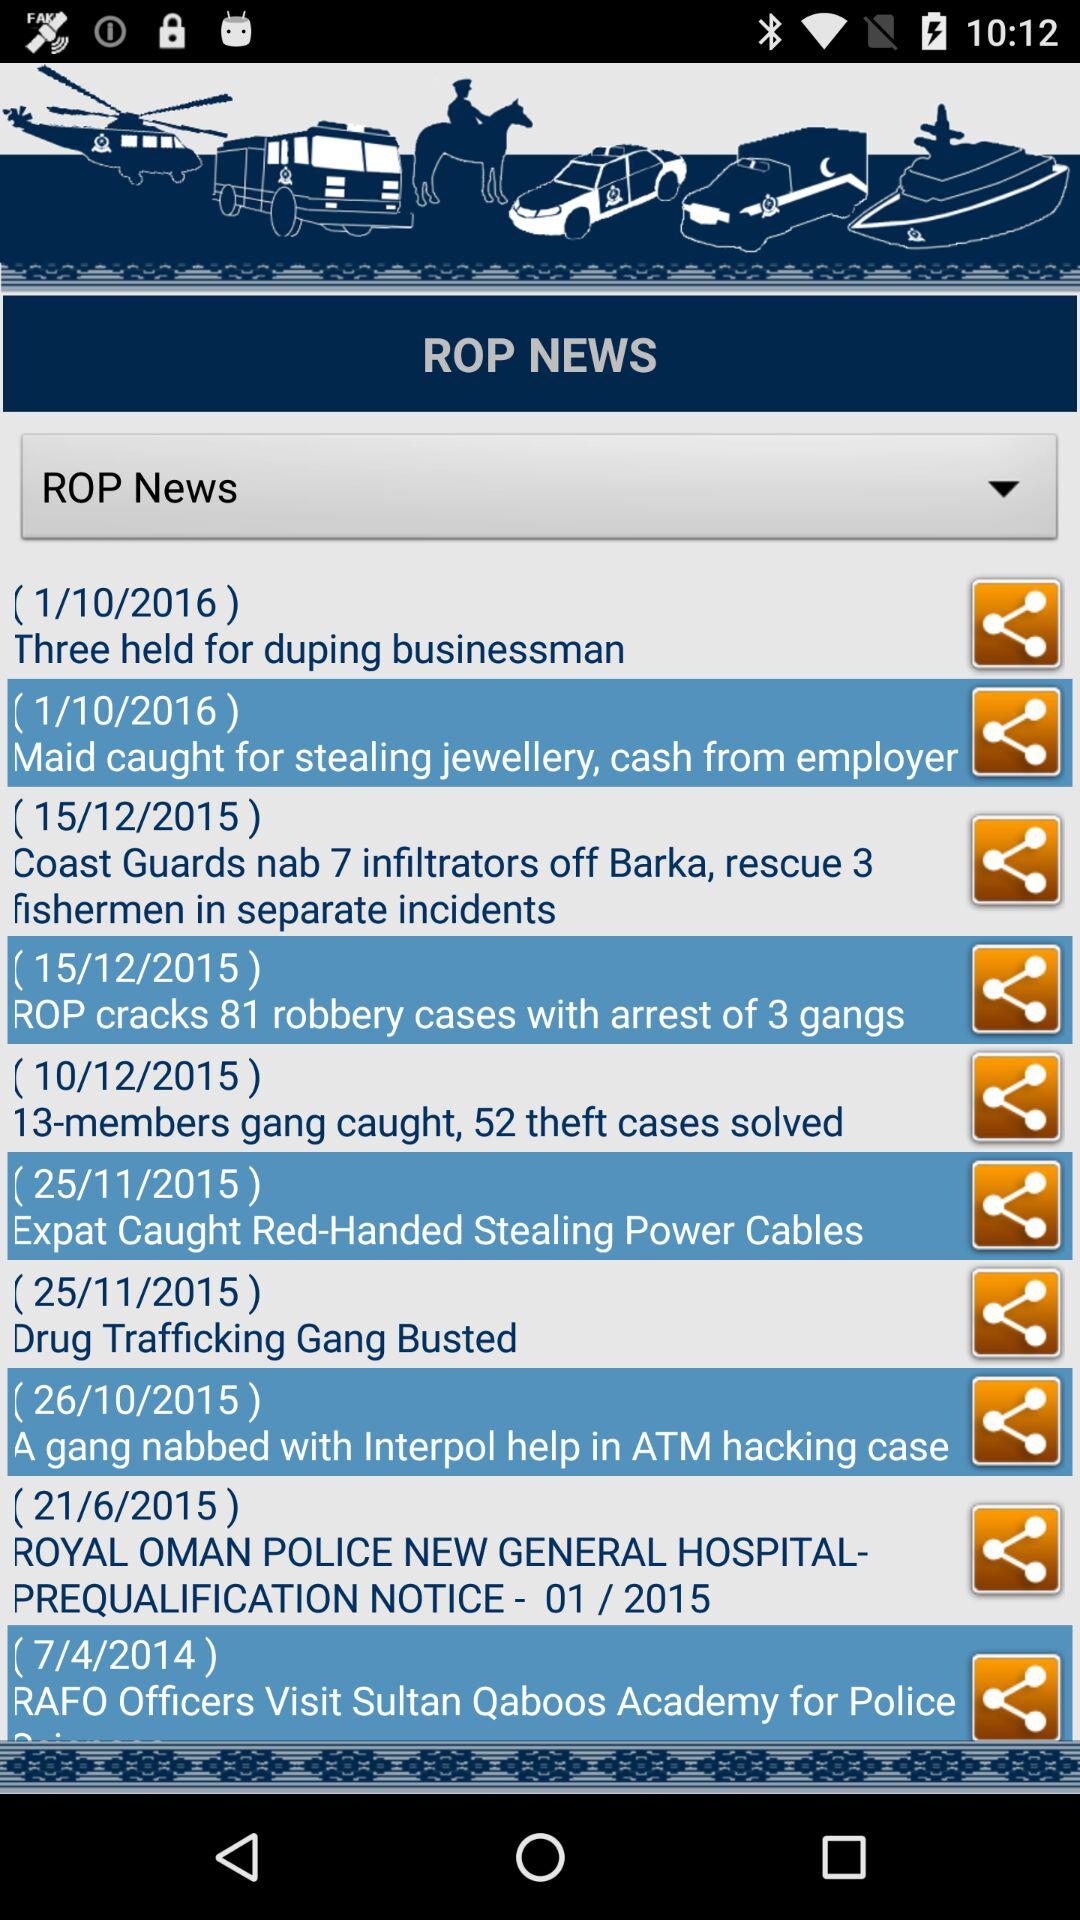Which news was posted on 1/10/2016? The news posted on January 10, 2016 is "Three held for duping businessman" and "Maid caught for stealing jewellery, cash from employer". 